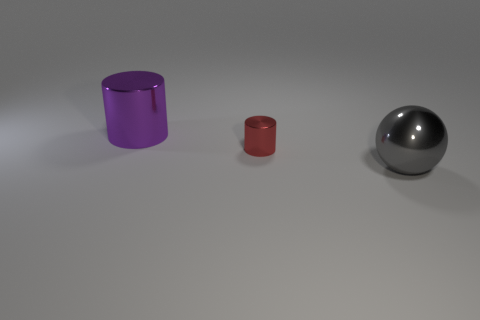There is a big metal object that is behind the big sphere; what is its shape?
Give a very brief answer. Cylinder. There is a big object that is in front of the shiny cylinder that is in front of the large metallic cylinder; what shape is it?
Offer a terse response. Sphere. Are there any small shiny objects of the same shape as the big purple metallic object?
Your answer should be compact. Yes. The other metal object that is the same size as the purple object is what shape?
Offer a very short reply. Sphere. There is a large object to the right of the cylinder to the right of the big shiny cylinder; are there any large purple cylinders in front of it?
Give a very brief answer. No. Is there a purple metal cylinder of the same size as the metal sphere?
Your response must be concise. Yes. What is the size of the cylinder that is in front of the large metallic cylinder?
Ensure brevity in your answer.  Small. There is a metal cylinder that is right of the large thing behind the big object in front of the purple shiny object; what color is it?
Make the answer very short. Red. The shiny cylinder that is in front of the large metal thing that is on the left side of the gray metallic thing is what color?
Ensure brevity in your answer.  Red. Are there more small red cylinders to the right of the purple shiny cylinder than small red things that are to the left of the red metal object?
Offer a terse response. Yes. 